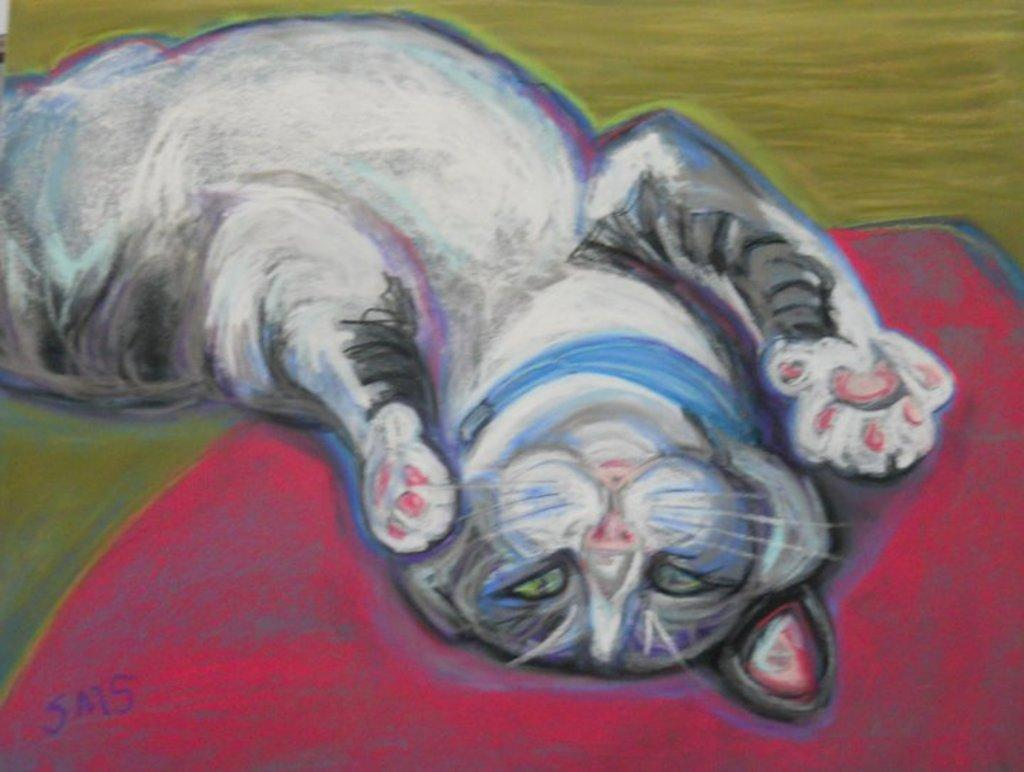What is the main subject of the painting in the image? There is a painting of a cat in the image. What type of quartz can be seen in the painting? There is no quartz present in the painting; it features a cat. How many members of the family are depicted in the painting? There are no family members depicted in the painting; it features a cat. 